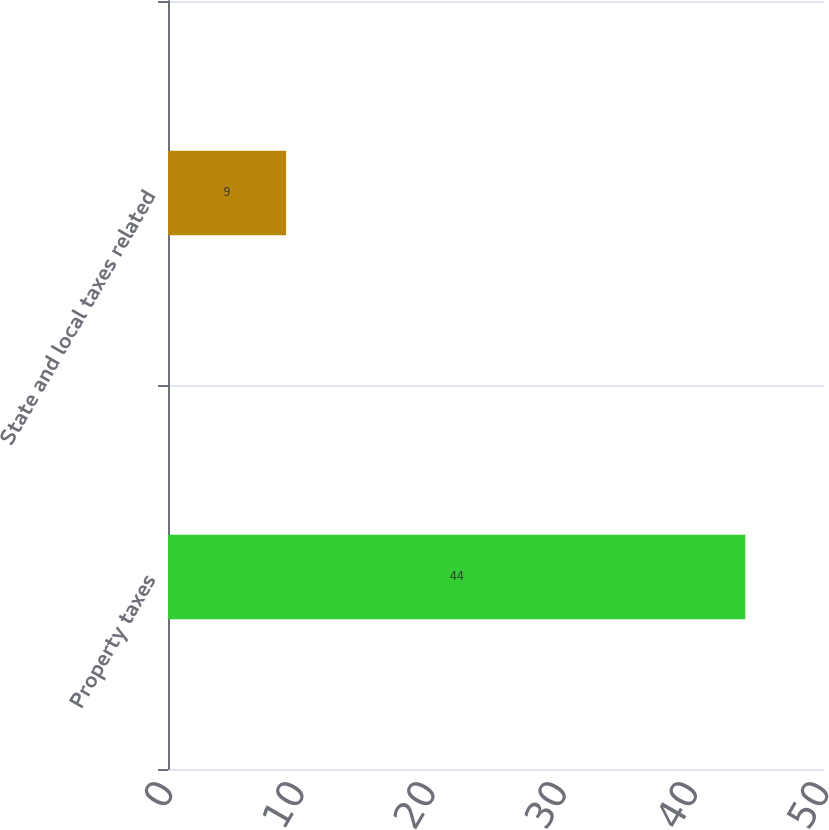Convert chart. <chart><loc_0><loc_0><loc_500><loc_500><bar_chart><fcel>Property taxes<fcel>State and local taxes related<nl><fcel>44<fcel>9<nl></chart> 